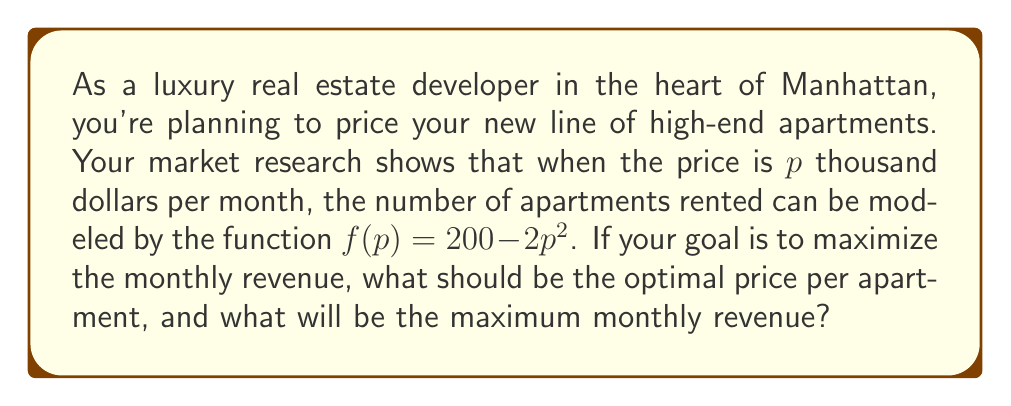Can you solve this math problem? Let's approach this step-by-step:

1) First, we need to define our revenue function. Revenue is price times quantity:
   $R(p) = p \cdot f(p) = p(200 - 2p^2)$

2) Expand this equation:
   $R(p) = 200p - 2p^3$

3) To find the maximum revenue, we need to find where the derivative of $R(p)$ equals zero:
   $\frac{dR}{dp} = 200 - 6p^2$

4) Set this equal to zero and solve for $p$:
   $200 - 6p^2 = 0$
   $6p^2 = 200$
   $p^2 = \frac{200}{6} \approx 33.33$
   $p = \sqrt{\frac{200}{6}} \approx 5.77$

5) To confirm this is a maximum, we can check the second derivative:
   $\frac{d^2R}{dp^2} = -12p$
   At $p \approx 5.77$, this is negative, confirming a maximum.

6) Now that we have the optimal price, we can calculate the maximum revenue:
   $R(5.77) = 200(5.77) - 2(5.77)^3 \approx 768.5$

Therefore, the optimal price is approximately $5,770 per month, and the maximum monthly revenue is about $768,500.
Answer: The optimal price for each luxury apartment is approximately $5,770 per month, and the maximum monthly revenue is about $768,500. 